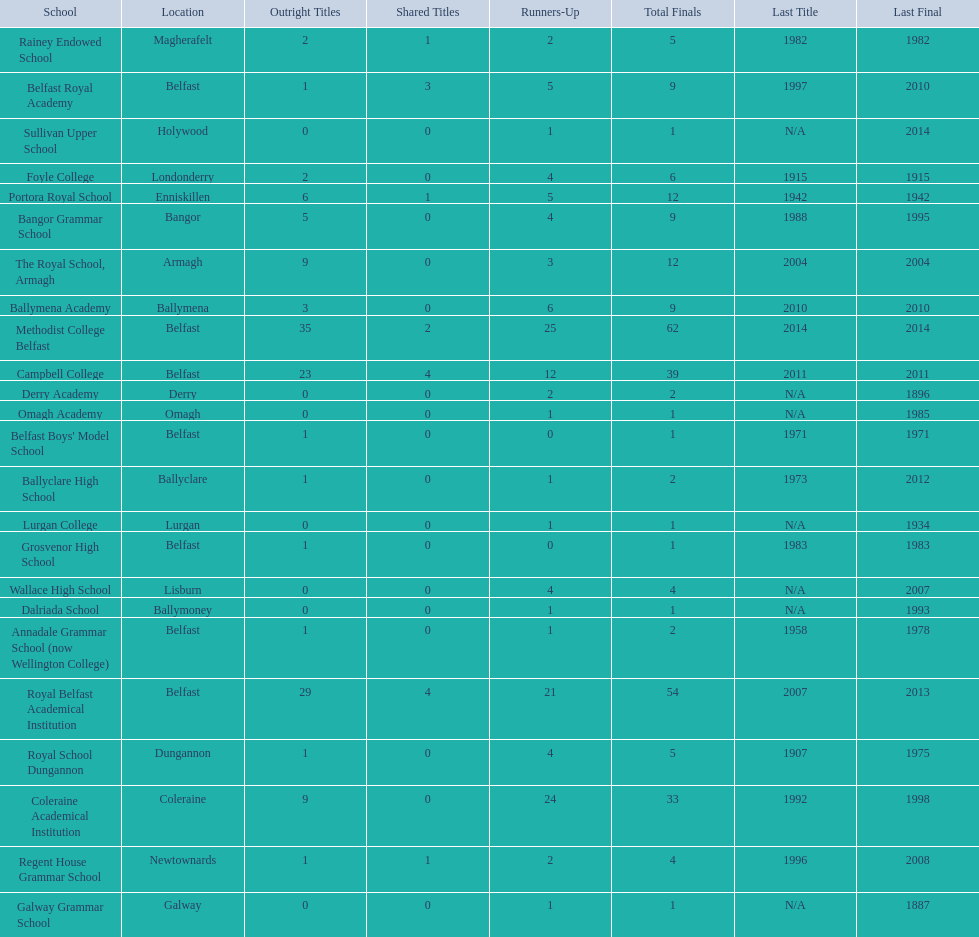What were all of the school names? Methodist College Belfast, Royal Belfast Academical Institution, Campbell College, Coleraine Academical Institution, The Royal School, Armagh, Portora Royal School, Bangor Grammar School, Ballymena Academy, Rainey Endowed School, Foyle College, Belfast Royal Academy, Regent House Grammar School, Royal School Dungannon, Annadale Grammar School (now Wellington College), Ballyclare High School, Belfast Boys' Model School, Grosvenor High School, Wallace High School, Derry Academy, Dalriada School, Galway Grammar School, Lurgan College, Omagh Academy, Sullivan Upper School. How many outright titles did they achieve? 35, 29, 23, 9, 9, 6, 5, 3, 2, 2, 1, 1, 1, 1, 1, 1, 1, 0, 0, 0, 0, 0, 0, 0. And how many did coleraine academical institution receive? 9. Which other school had the same number of outright titles? The Royal School, Armagh. 